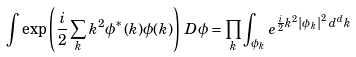<formula> <loc_0><loc_0><loc_500><loc_500>\int \exp \left ( { \frac { i } { 2 } } \sum _ { k } k ^ { 2 } \phi ^ { * } ( k ) \phi ( k ) \right ) \, D \phi = \prod _ { k } \int _ { \phi _ { k } } e ^ { { \frac { i } { 2 } } k ^ { 2 } \left | \phi _ { k } \right | ^ { 2 } \, d ^ { d } k }</formula> 